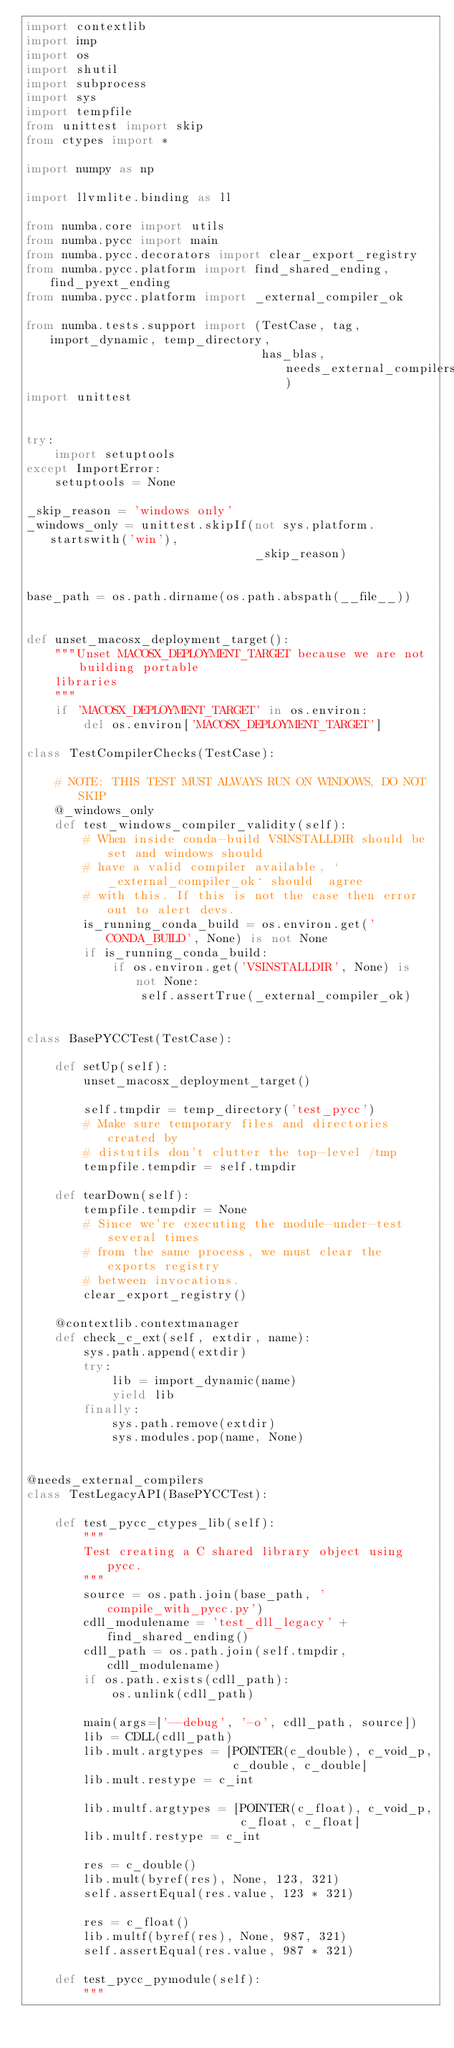<code> <loc_0><loc_0><loc_500><loc_500><_Python_>import contextlib
import imp
import os
import shutil
import subprocess
import sys
import tempfile
from unittest import skip
from ctypes import *

import numpy as np

import llvmlite.binding as ll

from numba.core import utils
from numba.pycc import main
from numba.pycc.decorators import clear_export_registry
from numba.pycc.platform import find_shared_ending, find_pyext_ending
from numba.pycc.platform import _external_compiler_ok

from numba.tests.support import (TestCase, tag, import_dynamic, temp_directory,
                                 has_blas, needs_external_compilers)
import unittest


try:
    import setuptools
except ImportError:
    setuptools = None

_skip_reason = 'windows only'
_windows_only = unittest.skipIf(not sys.platform.startswith('win'),
                                _skip_reason)


base_path = os.path.dirname(os.path.abspath(__file__))


def unset_macosx_deployment_target():
    """Unset MACOSX_DEPLOYMENT_TARGET because we are not building portable
    libraries
    """
    if 'MACOSX_DEPLOYMENT_TARGET' in os.environ:
        del os.environ['MACOSX_DEPLOYMENT_TARGET']

class TestCompilerChecks(TestCase):

    # NOTE: THIS TEST MUST ALWAYS RUN ON WINDOWS, DO NOT SKIP
    @_windows_only
    def test_windows_compiler_validity(self):
        # When inside conda-build VSINSTALLDIR should be set and windows should
        # have a valid compiler available, `_external_compiler_ok` should  agree
        # with this. If this is not the case then error out to alert devs.
        is_running_conda_build = os.environ.get('CONDA_BUILD', None) is not None
        if is_running_conda_build:
            if os.environ.get('VSINSTALLDIR', None) is not None:
                self.assertTrue(_external_compiler_ok)


class BasePYCCTest(TestCase):

    def setUp(self):
        unset_macosx_deployment_target()

        self.tmpdir = temp_directory('test_pycc')
        # Make sure temporary files and directories created by
        # distutils don't clutter the top-level /tmp
        tempfile.tempdir = self.tmpdir

    def tearDown(self):
        tempfile.tempdir = None
        # Since we're executing the module-under-test several times
        # from the same process, we must clear the exports registry
        # between invocations.
        clear_export_registry()

    @contextlib.contextmanager
    def check_c_ext(self, extdir, name):
        sys.path.append(extdir)
        try:
            lib = import_dynamic(name)
            yield lib
        finally:
            sys.path.remove(extdir)
            sys.modules.pop(name, None)


@needs_external_compilers
class TestLegacyAPI(BasePYCCTest):

    def test_pycc_ctypes_lib(self):
        """
        Test creating a C shared library object using pycc.
        """
        source = os.path.join(base_path, 'compile_with_pycc.py')
        cdll_modulename = 'test_dll_legacy' + find_shared_ending()
        cdll_path = os.path.join(self.tmpdir, cdll_modulename)
        if os.path.exists(cdll_path):
            os.unlink(cdll_path)

        main(args=['--debug', '-o', cdll_path, source])
        lib = CDLL(cdll_path)
        lib.mult.argtypes = [POINTER(c_double), c_void_p,
                             c_double, c_double]
        lib.mult.restype = c_int

        lib.multf.argtypes = [POINTER(c_float), c_void_p,
                              c_float, c_float]
        lib.multf.restype = c_int

        res = c_double()
        lib.mult(byref(res), None, 123, 321)
        self.assertEqual(res.value, 123 * 321)

        res = c_float()
        lib.multf(byref(res), None, 987, 321)
        self.assertEqual(res.value, 987 * 321)

    def test_pycc_pymodule(self):
        """</code> 